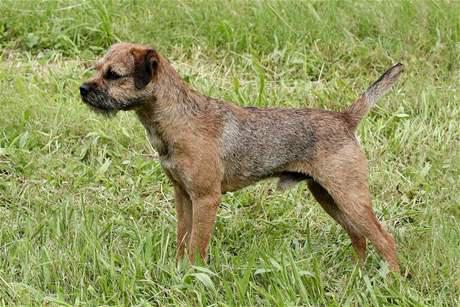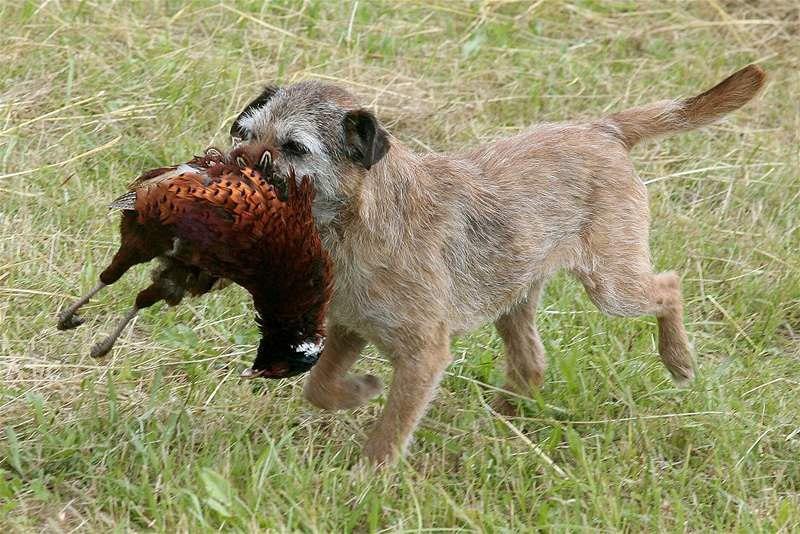The first image is the image on the left, the second image is the image on the right. Assess this claim about the two images: "a dog is carrying a dead animal in it's mouth". Correct or not? Answer yes or no. Yes. The first image is the image on the left, the second image is the image on the right. Analyze the images presented: Is the assertion "One of the pictures has a dog carrying another animal in its mouth." valid? Answer yes or no. Yes. 